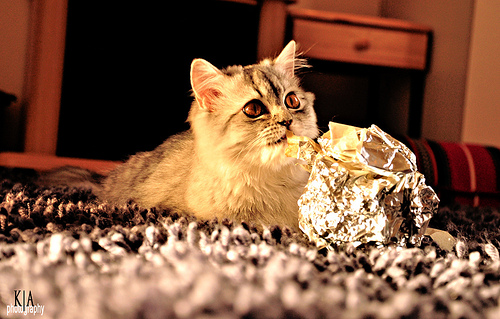<image>
Is there a cat on the table? No. The cat is not positioned on the table. They may be near each other, but the cat is not supported by or resting on top of the table. Is there a cat under the drawer? No. The cat is not positioned under the drawer. The vertical relationship between these objects is different. 